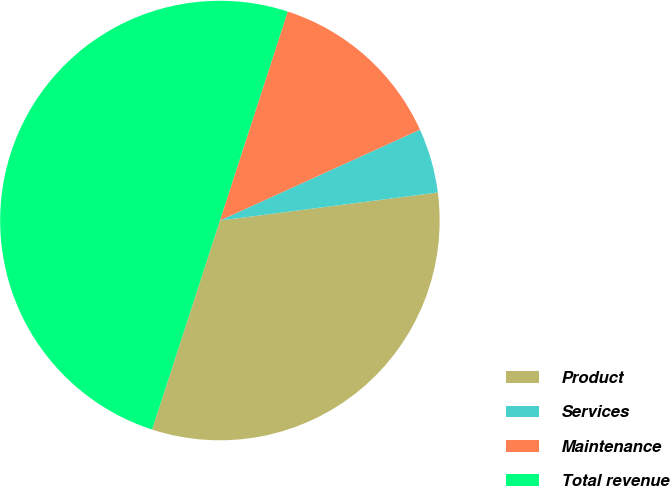Convert chart. <chart><loc_0><loc_0><loc_500><loc_500><pie_chart><fcel>Product<fcel>Services<fcel>Maintenance<fcel>Total revenue<nl><fcel>32.03%<fcel>4.75%<fcel>13.22%<fcel>50.0%<nl></chart> 